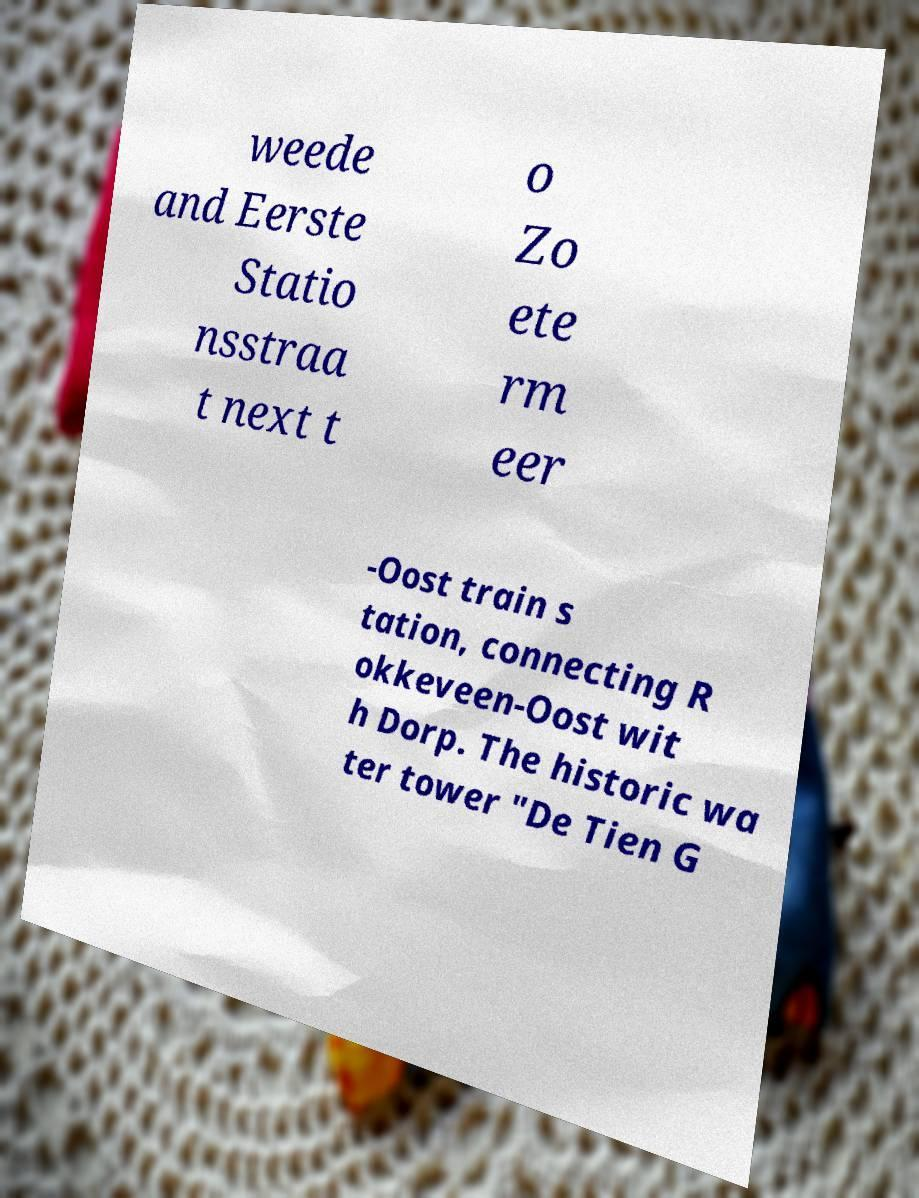For documentation purposes, I need the text within this image transcribed. Could you provide that? weede and Eerste Statio nsstraa t next t o Zo ete rm eer -Oost train s tation, connecting R okkeveen-Oost wit h Dorp. The historic wa ter tower "De Tien G 